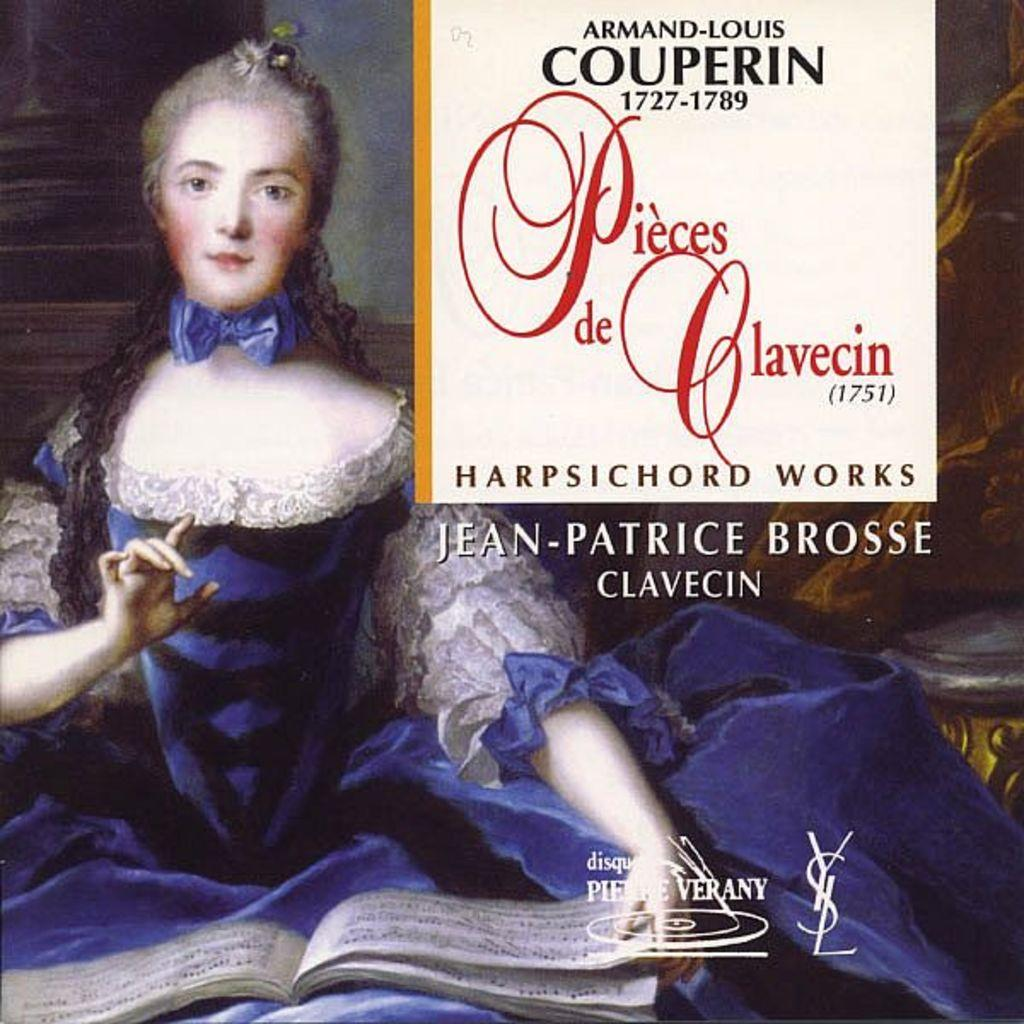<image>
Provide a brief description of the given image. The cover shows a woman in an old purple dress as one of the works of Armand-Louis Couperin. 